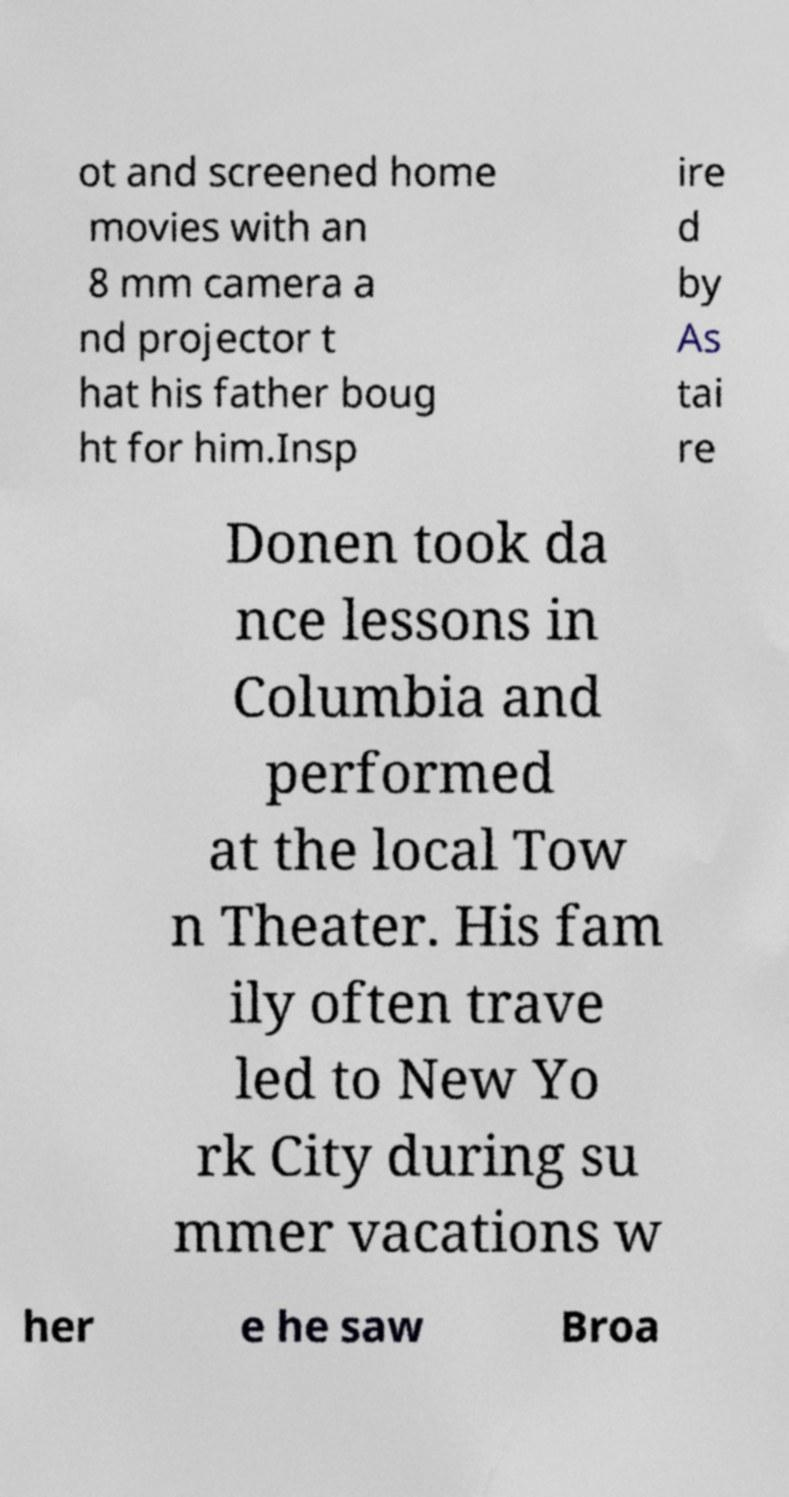I need the written content from this picture converted into text. Can you do that? ot and screened home movies with an 8 mm camera a nd projector t hat his father boug ht for him.Insp ire d by As tai re Donen took da nce lessons in Columbia and performed at the local Tow n Theater. His fam ily often trave led to New Yo rk City during su mmer vacations w her e he saw Broa 